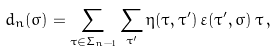<formula> <loc_0><loc_0><loc_500><loc_500>d _ { n } ( \sigma ) = \sum _ { \tau \in \Sigma _ { n - 1 } } \sum _ { \tau ^ { \prime } } \eta ( \tau , \tau ^ { \prime } ) \, \varepsilon ( \tau ^ { \prime } , \sigma ) \, \tau \, ,</formula> 